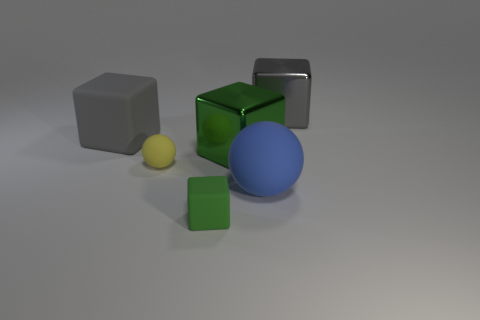Subtract all cyan cubes. Subtract all gray cylinders. How many cubes are left? 4 Add 3 small matte spheres. How many objects exist? 9 Subtract all blocks. How many objects are left? 2 Add 6 gray blocks. How many gray blocks are left? 8 Add 3 gray metallic spheres. How many gray metallic spheres exist? 3 Subtract 0 brown spheres. How many objects are left? 6 Subtract all spheres. Subtract all red shiny objects. How many objects are left? 4 